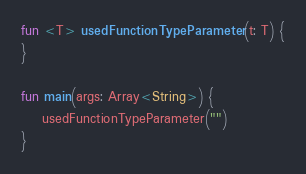<code> <loc_0><loc_0><loc_500><loc_500><_Kotlin_>fun <T> usedFunctionTypeParameter(t: T) {
}

fun main(args: Array<String>) {
    usedFunctionTypeParameter("")
}</code> 